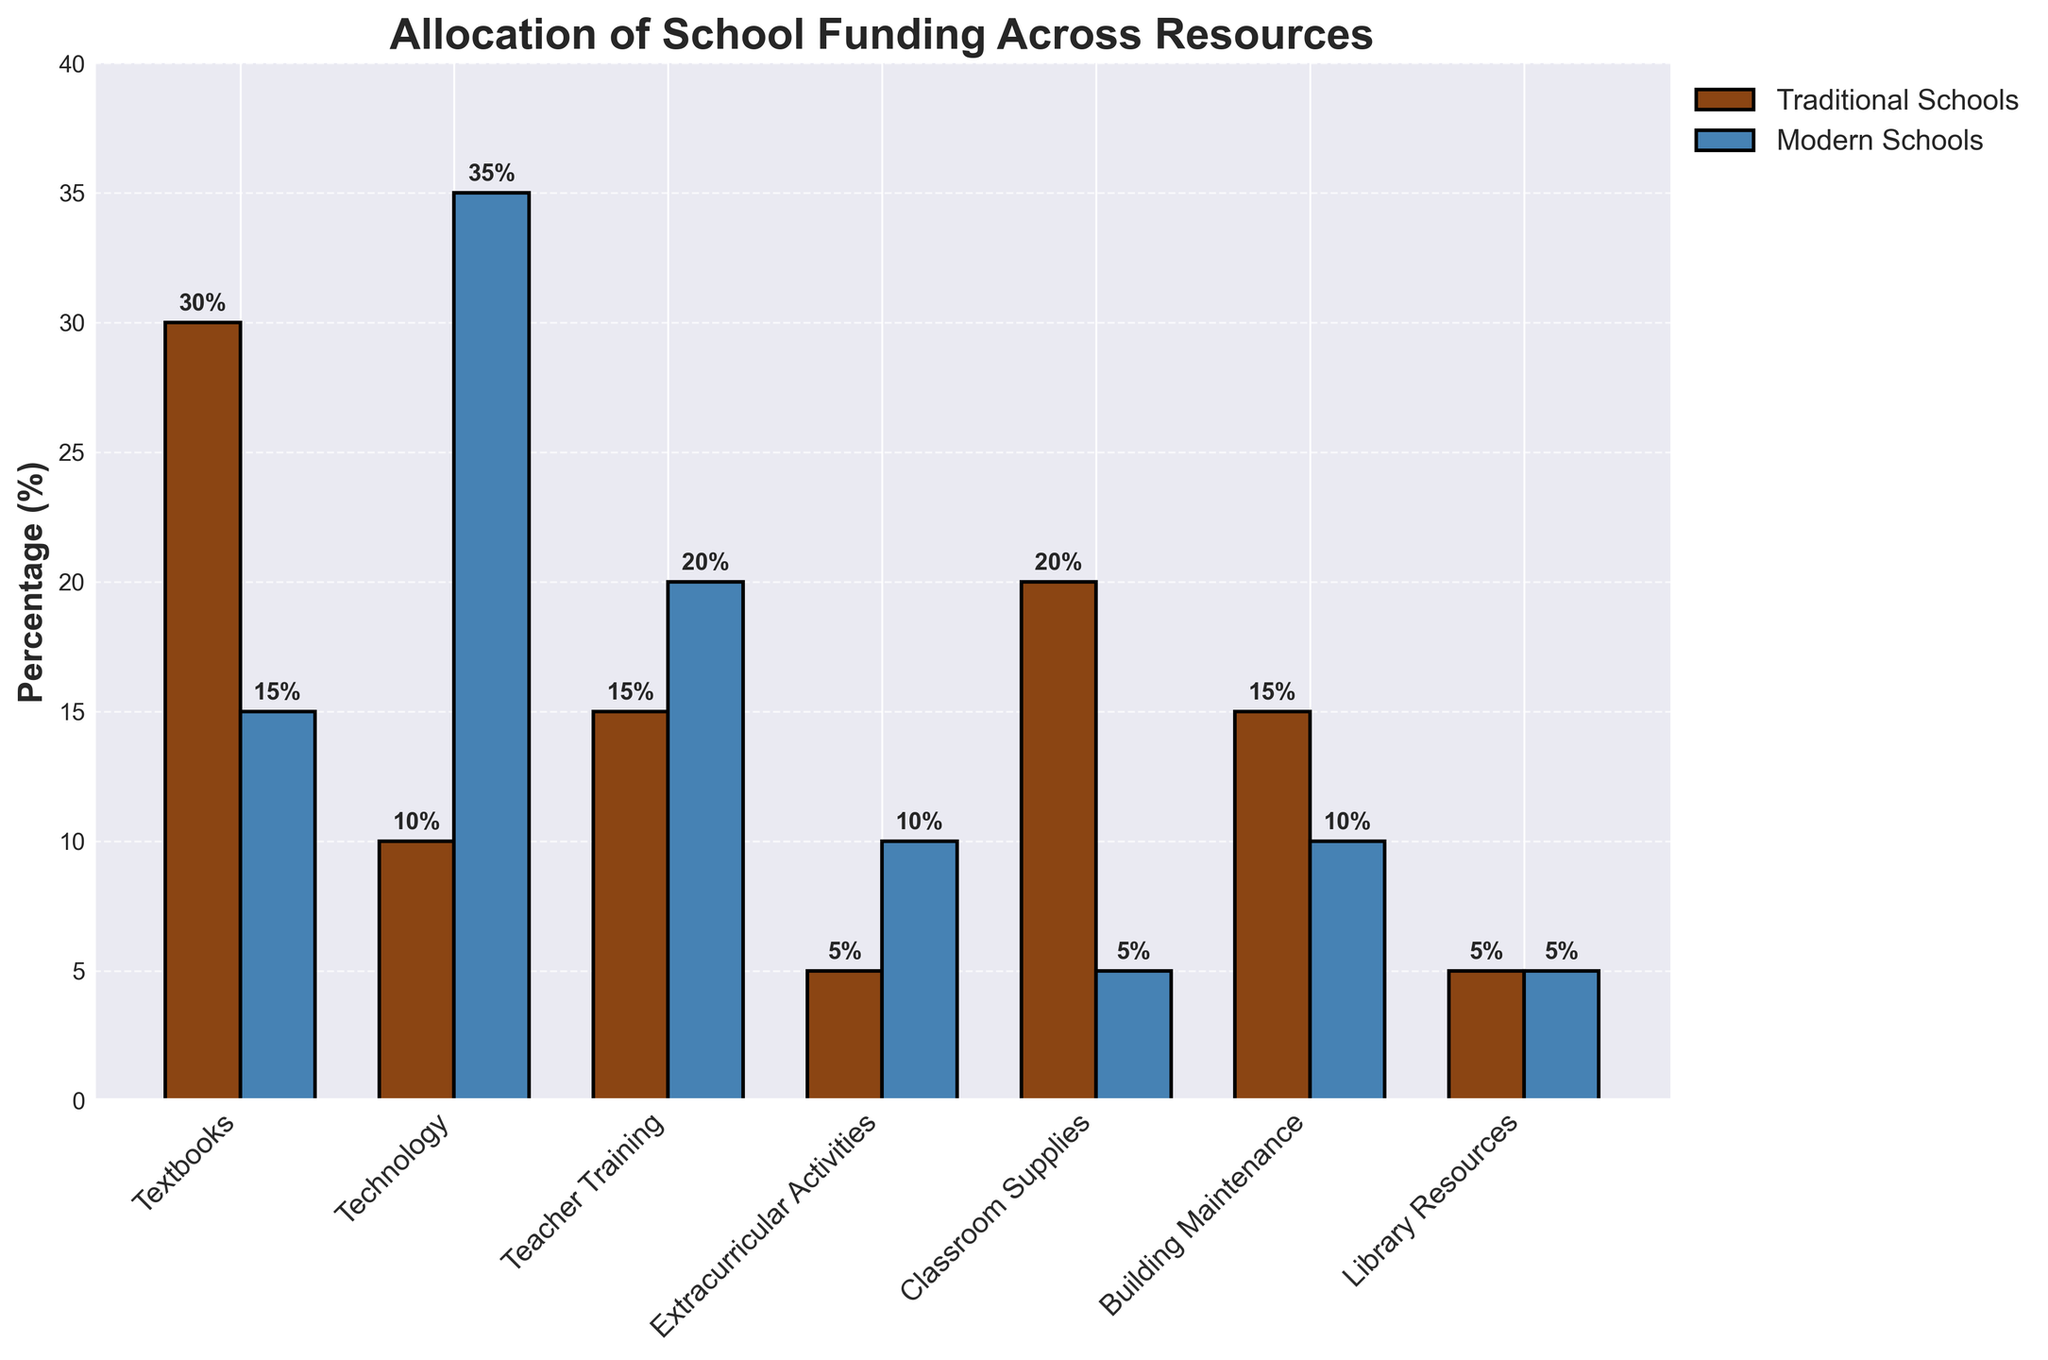What resource in traditional schools received the highest percentage of funding? The tallest bar for traditional schools corresponds to the resource with the highest percentage of funding. From the figure, it is Textbooks at 30%.
Answer: Textbooks Which resource in modern schools received the least percentage of funding? The shortest bar for modern schools will indicate the resource with the least funding. Both Classroom Supplies and Library Resources have the shortest bars at 5%.
Answer: Classroom Supplies and Library Resources What is the difference in funding percentage for technology between traditional and modern schools? Find the heights of the two technology bars and subtract the traditional school's value from the modern school's value. That is 35% - 10% = 25%.
Answer: 25% How much more funding percentage does modern schools allocate to extracurricular activities compared to traditional schools? The heights of the extracurricular activities bars in modern and traditional schools show the difference. Modern schools allocate 10% whereas traditional schools allocate 5%. The difference is 10% - 5% = 5%.
Answer: 5% What is the combined funding percentage of teacher training and library resources in modern schools? Sum the heights of the teacher training and library resources bars for modern schools. Teacher Training is 20%, and Library Resources is 5%, so 20% + 5% = 25%.
Answer: 25% Which resource sees the largest difference in funding allocation between traditional and modern schools? Compare the differences in the heights of each pair of bars (one traditional and one modern) for each resource. The largest difference is in technology: 35% - 10% = 25%.
Answer: Technology By how many percentage points does the funding for classroom supplies in traditional schools exceed that in modern schools? The traditional schools' funding for classroom supplies is 20%, while modern schools have 5%. The difference is 20% - 5% = 15%.
Answer: 15% What is the total percentage of funding allocated to technology and teacher training in traditional schools? Add the funding percentages for technology and teacher training in traditional schools. Technology is 10% and teacher training is 15%. Thus: 10% + 15% = 25%.
Answer: 25% Are there any resources where traditional and modern schools allocate the same percentage of funding? If yes, which resource(s)? Compare the heights of the bars for all resources to see if any pairs are equal. Both traditional and modern schools allocate the same percentage to library resources, each at 5%.
Answer: Library Resources How much more funding percentage does modern schools allocate to technology compared to textbooks? In modern schools, compare the funding percentage for technology (35%) with textbooks (15%) and find the difference. Thus, 35% - 15% = 20%.
Answer: 20% 